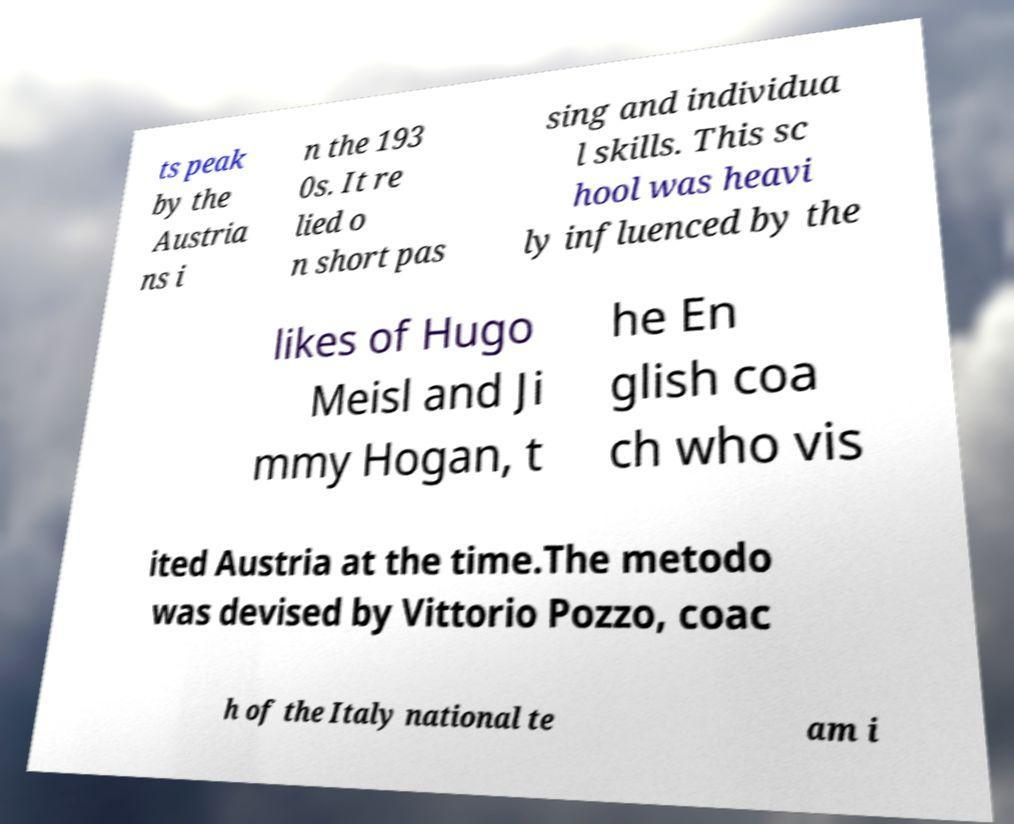Please identify and transcribe the text found in this image. ts peak by the Austria ns i n the 193 0s. It re lied o n short pas sing and individua l skills. This sc hool was heavi ly influenced by the likes of Hugo Meisl and Ji mmy Hogan, t he En glish coa ch who vis ited Austria at the time.The metodo was devised by Vittorio Pozzo, coac h of the Italy national te am i 